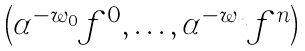<formula> <loc_0><loc_0><loc_500><loc_500>\begin{pmatrix} \alpha ^ { - w _ { 0 } } f ^ { 0 } , \dots , \alpha ^ { - w _ { n } } f ^ { n } \end{pmatrix}</formula> 